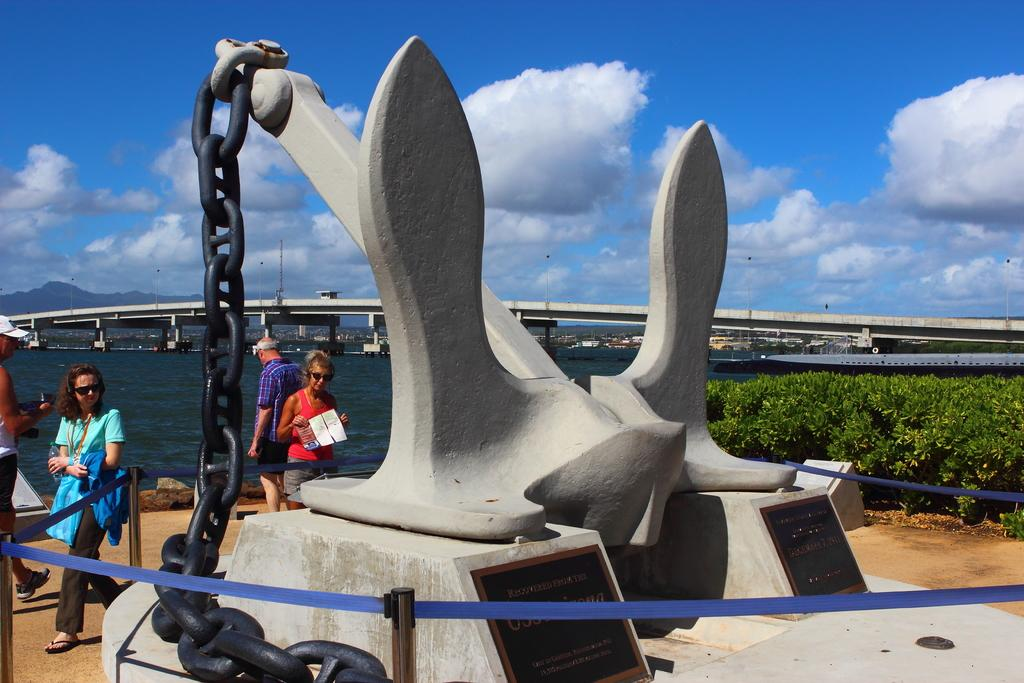What is the main subject in the center of the image? There is a sculpture in the center of the image. Can you describe the people in the image? There are people in the image, but their specific actions or positions are not mentioned in the facts. What type of vegetation is on the right side of the image? There are plants on the right side of the image. What can be seen in the background of the image? There is a bridge, hills, and the sky visible in the background of the image. Is there any water present in the image? Yes, there is water present in the image. Where is the toy located in the image? There is no toy present in the image. Can you describe the sound of the people sneezing in the image? There is no mention of people sneezing in the image, so it is not possible to describe the sound. 